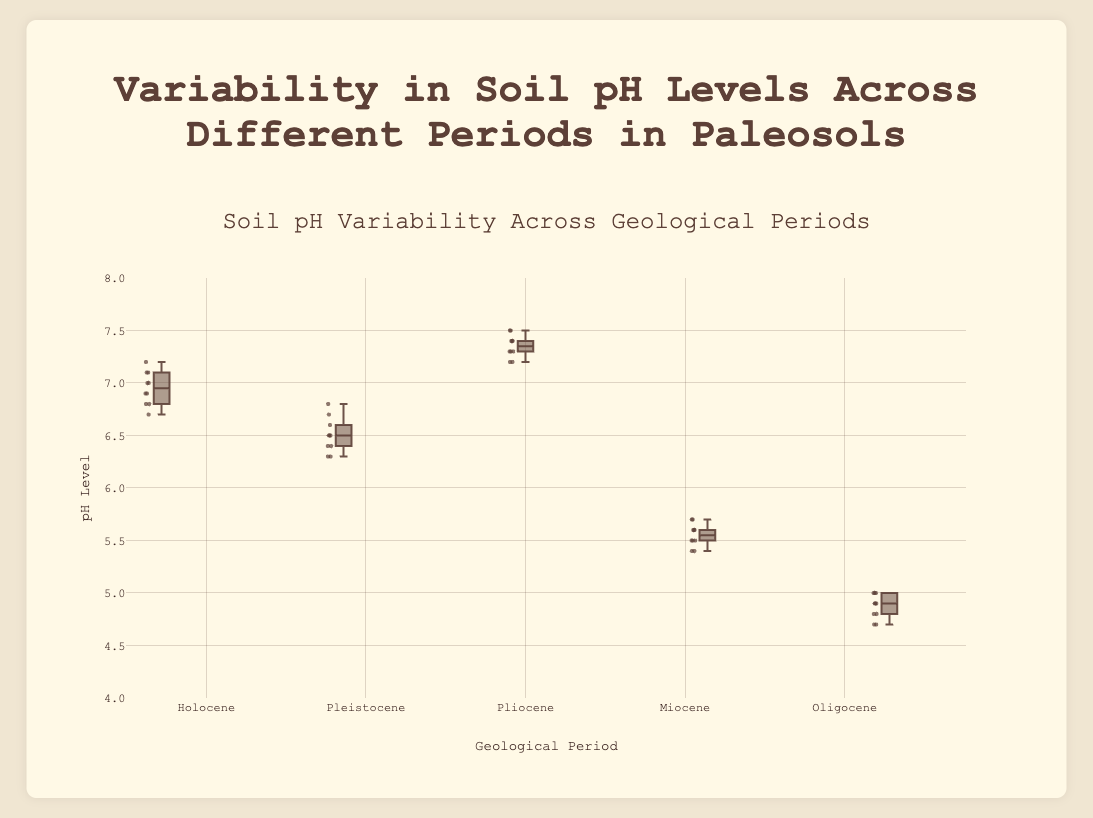What is the title of the figure? The title of the figure is clearly displayed at the top. It reads "Soil pH Variability Across Geological Periods."
Answer: Soil pH Variability Across Geological Periods How many geological periods are represented in the box plot? The box plot shows distinct boxes for five different names representing the geological periods: Holocene, Pleistocene, Pliocene, Miocene, and Oligocene.
Answer: Five Which geological period has the highest median pH level? By examining the horizontal lines inside the boxes of the box plot, which represent the medians, the Pliocene period has the highest median value among all.
Answer: Pliocene What is the approximate range of pH levels in the Miocene period? The range is the difference between the minimum and maximum values represented by the lower and upper whiskers of the Miocene box plot. The whiskers are at approximately 5.4 and 5.7.
Answer: 5.4 to 5.7 Compare the spread of pH levels between the Holocene and Oligocene periods. The spread or variability of a box plot is indicated by the length of the box. The Holocene has a box ranging from about 6.7 to 7.1, while the Oligocene has a box from about 4.7 to 5.0, indicating the Holocene pH spread is larger.
Answer: Holocene has a larger spread Which period exhibits the lowest overall pH values? By looking at the minimum whiskers in all box plots, the Oligocene period has the lowest values with the whiskers going down to approximately 4.7.
Answer: Oligocene What can be inferred about the consistency of pH levels during the Pleistocene compared to the Pliocene? The box plot for Pleistocene has a narrower box and whiskers compared to the Pliocene, suggesting lower variability and more consistent pH levels during the Pleistocene period.
Answer: Pleistocene has more consistent pH levels Is there any overlap in the pH ranges of the Miocene and the Pleistocene periods? By comparing the whiskers and boxes of Miocene and Pleistocene, there is no overlap since Miocene ranges from 5.4 to 5.7 and Pleistocene ranges from 6.3 to 6.8 which are distinct ranges.
Answer: No What is the interquartile range (IQR) of pH levels for the Pliocene period? The IQR is the range between the first quartile (Q1) and third quartile (Q3) of the box. For Pliocene, Q1 is at around 7.2 and Q3 is at about 7.4. So, IQR is 7.4 - 7.2 = 0.2.
Answer: 0.2 Which period shows the greatest variability in pH levels and how can you tell? The period with the greatest variability has the longest box and whiskers. The Holocene shows the largest spread from about 6.7 to 7.2.
Answer: Holocene 